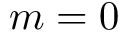<formula> <loc_0><loc_0><loc_500><loc_500>m = 0</formula> 